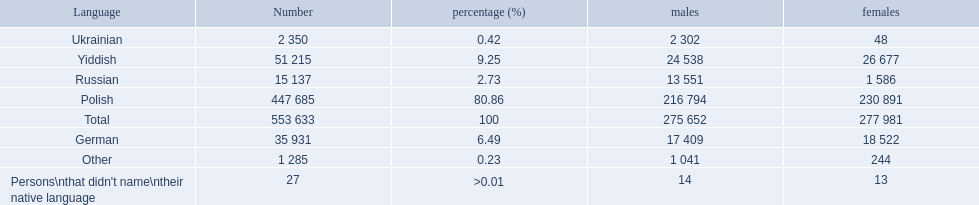What language makes a majority Polish. What the the total number of speakers? 553 633. Parse the full table. {'header': ['Language', 'Number', 'percentage (%)', 'males', 'females'], 'rows': [['Ukrainian', '2 350', '0.42', '2 302', '48'], ['Yiddish', '51 215', '9.25', '24 538', '26 677'], ['Russian', '15 137', '2.73', '13 551', '1 586'], ['Polish', '447 685', '80.86', '216 794', '230 891'], ['Total', '553 633', '100', '275 652', '277 981'], ['German', '35 931', '6.49', '17 409', '18 522'], ['Other', '1 285', '0.23', '1 041', '244'], ["Persons\\nthat didn't name\\ntheir native language", '27', '>0.01', '14', '13']]} 